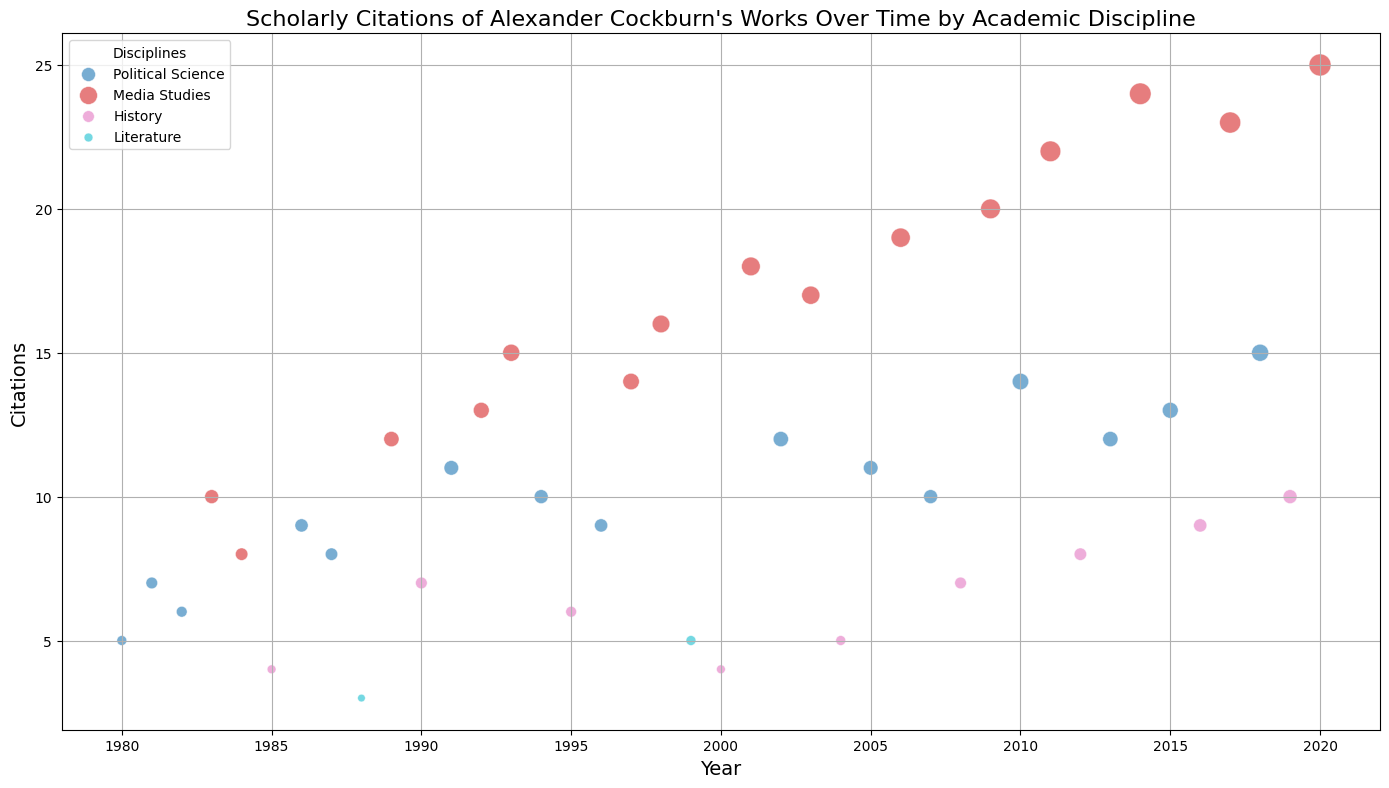Which discipline shows the highest number of citations in 2014? To determine this, locate the year 2014 on the x-axis. Look for the bubble that corresponds to the highest point on the y-axis in that year. The highest bubble in 2014 represents the "Media Studies" discipline.
Answer: Media Studies How many total citations were there in Media Studies in 2017 and 2018? Locate the bubbles for Media Studies in the years 2017 and 2018. In 2017, Media Studies has 23 citations, and in 2018, it has 15 citations. Summing these values gives us 23 + 15 = 38.
Answer: 38 In which year did Political Science have its peak citation count, and what was the count? Look through the bubbles for Political Science and identify the one at the highest position on the y-axis. This occurs in 2018 with 15 citations.
Answer: 2018, 15 How do the citation trends of Media Studies and Political Science compare over time? Observe the positions of the bubbles over the years for both Media Studies and Political Science. Media Studies shows a general increasing trend in citations over time, while Political Science shows fluctuations with several peaks but no clear upward trend.
Answer: Media Studies shows an increasing trend, while Political Science fluctuates What is the average number of citations for History from 1980 to 2020? Identify the citation counts for History from the relevant years: 4, 7, 6, 4, 5, 7, 8, 9, 10. Sum these values (4 + 7 + 6 + 4 + 5 + 7 + 8 + 9 + 10 = 60). Divide by the number of data points (9), resulting in an average of 60/9 = 6.67.
Answer: 6.67 